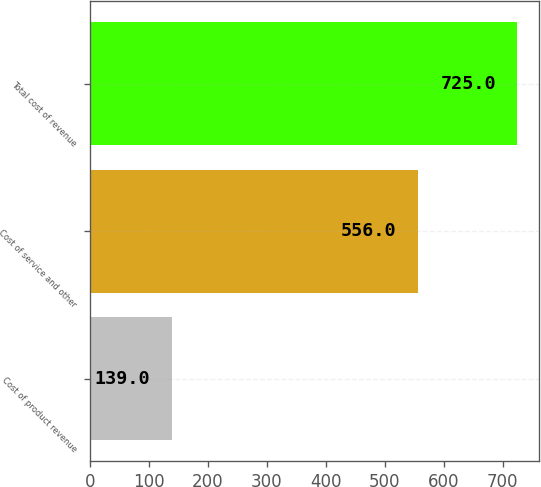Convert chart to OTSL. <chart><loc_0><loc_0><loc_500><loc_500><bar_chart><fcel>Cost of product revenue<fcel>Cost of service and other<fcel>Total cost of revenue<nl><fcel>139<fcel>556<fcel>725<nl></chart> 